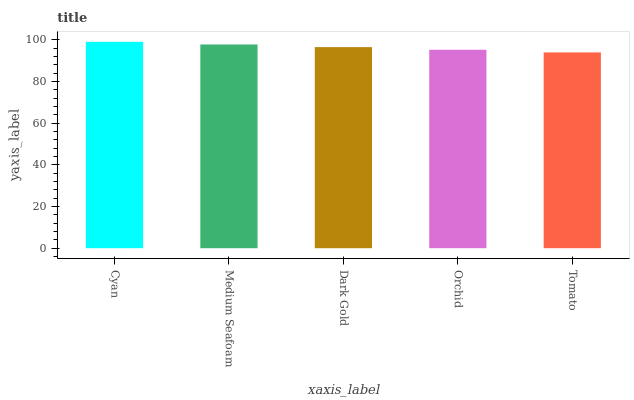Is Tomato the minimum?
Answer yes or no. Yes. Is Cyan the maximum?
Answer yes or no. Yes. Is Medium Seafoam the minimum?
Answer yes or no. No. Is Medium Seafoam the maximum?
Answer yes or no. No. Is Cyan greater than Medium Seafoam?
Answer yes or no. Yes. Is Medium Seafoam less than Cyan?
Answer yes or no. Yes. Is Medium Seafoam greater than Cyan?
Answer yes or no. No. Is Cyan less than Medium Seafoam?
Answer yes or no. No. Is Dark Gold the high median?
Answer yes or no. Yes. Is Dark Gold the low median?
Answer yes or no. Yes. Is Cyan the high median?
Answer yes or no. No. Is Orchid the low median?
Answer yes or no. No. 